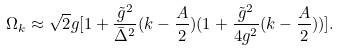<formula> <loc_0><loc_0><loc_500><loc_500>\Omega _ { k } \approx \sqrt { 2 } g [ 1 + \frac { \tilde { g } ^ { 2 } } { \bar { \Delta } ^ { 2 } } ( k - \frac { A } { 2 } ) ( 1 + \frac { \tilde { g } ^ { 2 } } { 4 g ^ { 2 } } ( k - \frac { A } { 2 } ) ) ] .</formula> 